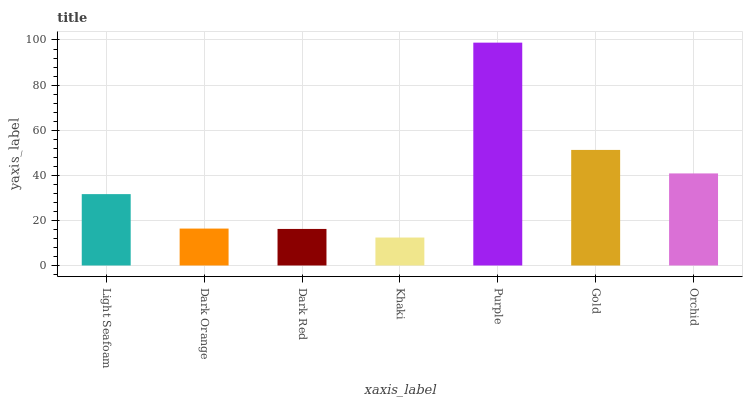Is Dark Orange the minimum?
Answer yes or no. No. Is Dark Orange the maximum?
Answer yes or no. No. Is Light Seafoam greater than Dark Orange?
Answer yes or no. Yes. Is Dark Orange less than Light Seafoam?
Answer yes or no. Yes. Is Dark Orange greater than Light Seafoam?
Answer yes or no. No. Is Light Seafoam less than Dark Orange?
Answer yes or no. No. Is Light Seafoam the high median?
Answer yes or no. Yes. Is Light Seafoam the low median?
Answer yes or no. Yes. Is Dark Red the high median?
Answer yes or no. No. Is Khaki the low median?
Answer yes or no. No. 